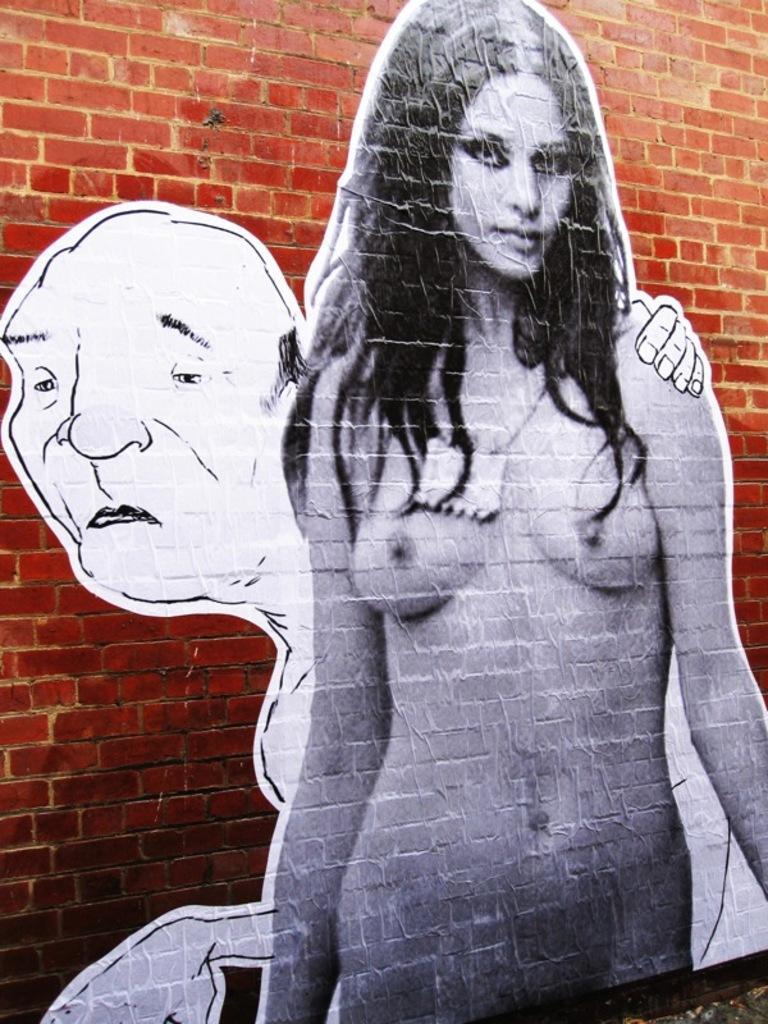What is depicted on the wall in the image? There are posts of people on the wall in the image. Can you describe the content of the posts? The posts feature images or pictures of people. How many posts are visible in the image? The number of posts cannot be determined from the provided fact, but there are at least some posts visible on the wall. How does the son help sort the arm in the image? There is no son or arm present in the image; it only features posts of people on the wall. 